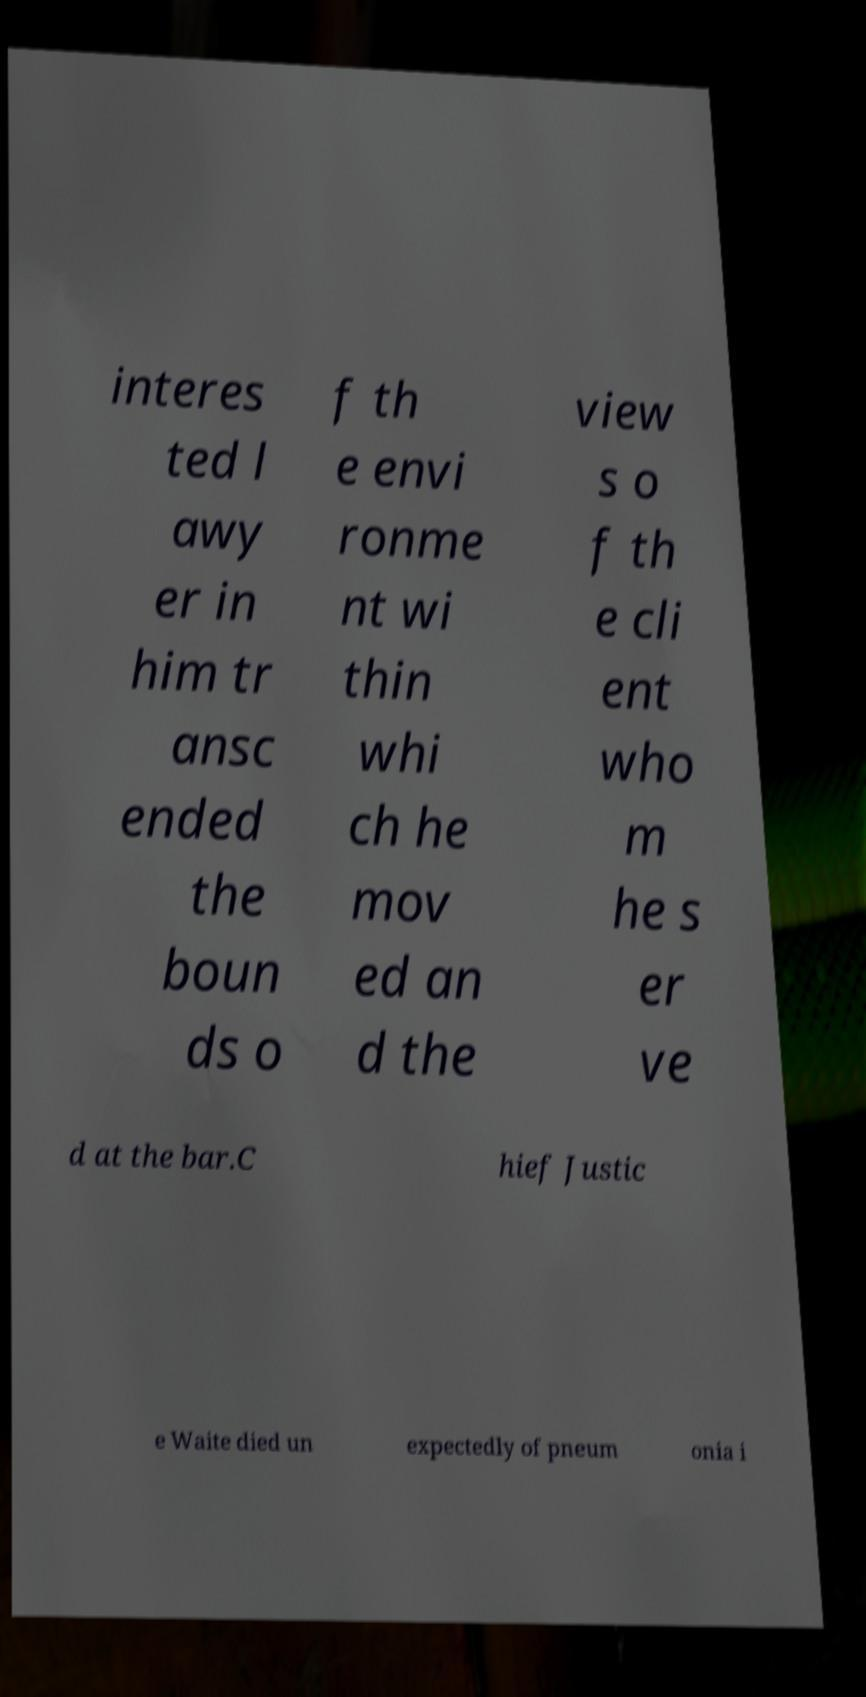Please identify and transcribe the text found in this image. interes ted l awy er in him tr ansc ended the boun ds o f th e envi ronme nt wi thin whi ch he mov ed an d the view s o f th e cli ent who m he s er ve d at the bar.C hief Justic e Waite died un expectedly of pneum onia i 